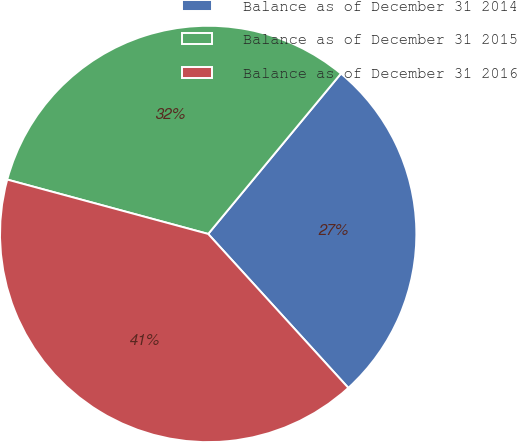Convert chart to OTSL. <chart><loc_0><loc_0><loc_500><loc_500><pie_chart><fcel>Balance as of December 31 2014<fcel>Balance as of December 31 2015<fcel>Balance as of December 31 2016<nl><fcel>27.24%<fcel>31.8%<fcel>40.96%<nl></chart> 